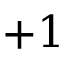<formula> <loc_0><loc_0><loc_500><loc_500>+ 1</formula> 